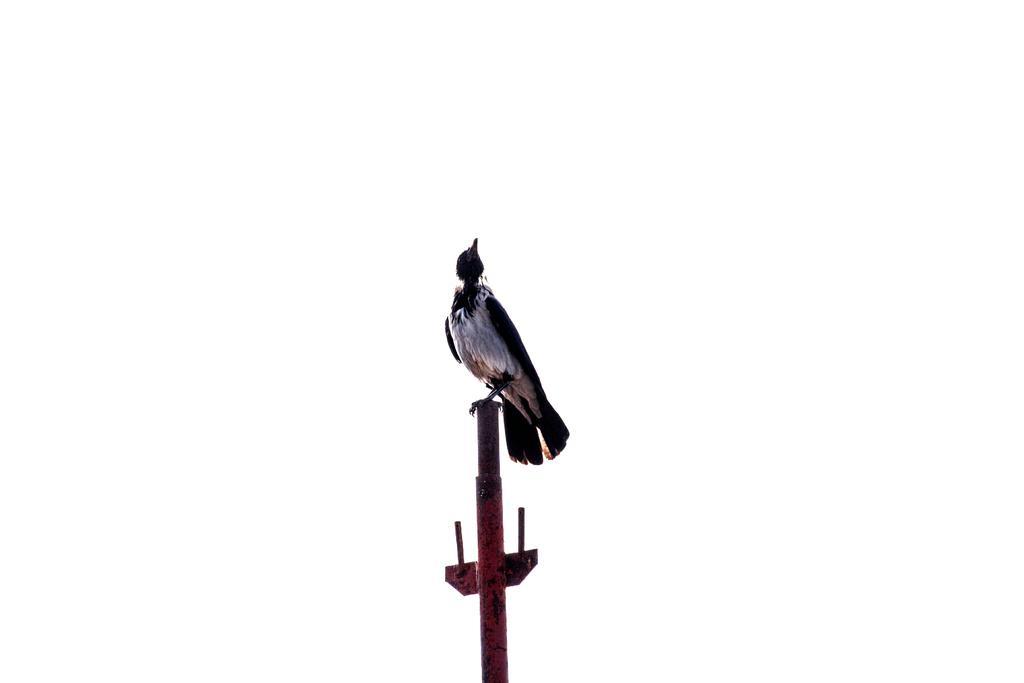How would you summarize this image in a sentence or two? In this picture there is a black color crow sitting on the iron pole. Behind there is a white background. 